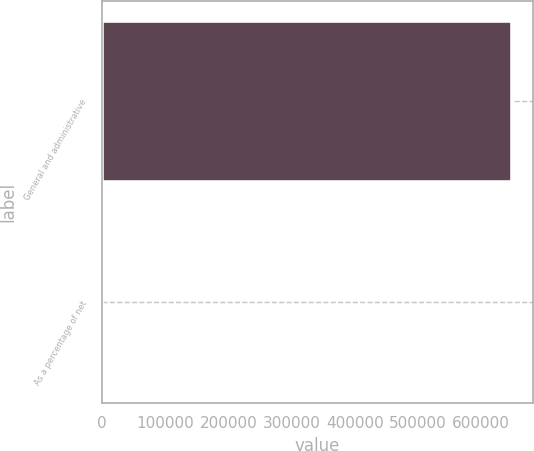<chart> <loc_0><loc_0><loc_500><loc_500><bar_chart><fcel>General and administrative<fcel>As a percentage of net<nl><fcel>649529<fcel>14.3<nl></chart> 